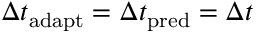Convert formula to latex. <formula><loc_0><loc_0><loc_500><loc_500>\Delta t _ { a d a p t } = \Delta t _ { p r e d } = \Delta t</formula> 